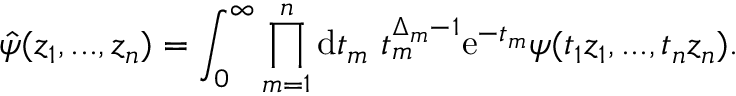Convert formula to latex. <formula><loc_0><loc_0><loc_500><loc_500>\hat { \psi } ( z _ { 1 } , \dots , z _ { n } ) = \int _ { 0 } ^ { \infty } \prod _ { m = 1 } ^ { n } d t _ { m } \ t _ { m } ^ { \Delta _ { m } - 1 } e ^ { - t _ { m } } \psi ( t _ { 1 } z _ { 1 } , \dots , t _ { n } z _ { n } ) .</formula> 